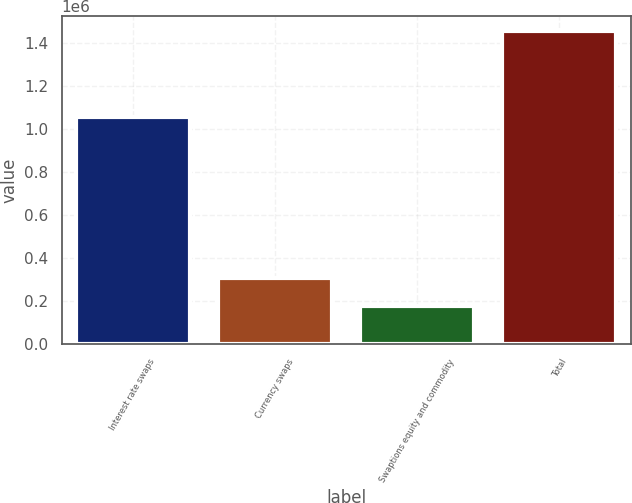Convert chart. <chart><loc_0><loc_0><loc_500><loc_500><bar_chart><fcel>Interest rate swaps<fcel>Currency swaps<fcel>Swaptions equity and commodity<fcel>Total<nl><fcel>1.05828e+06<fcel>307677<fcel>180040<fcel>1.45641e+06<nl></chart> 